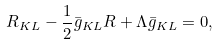Convert formula to latex. <formula><loc_0><loc_0><loc_500><loc_500>R _ { K L } - \frac { 1 } { 2 } \bar { g } _ { K L } R + \Lambda \bar { g } _ { K L } = 0 ,</formula> 